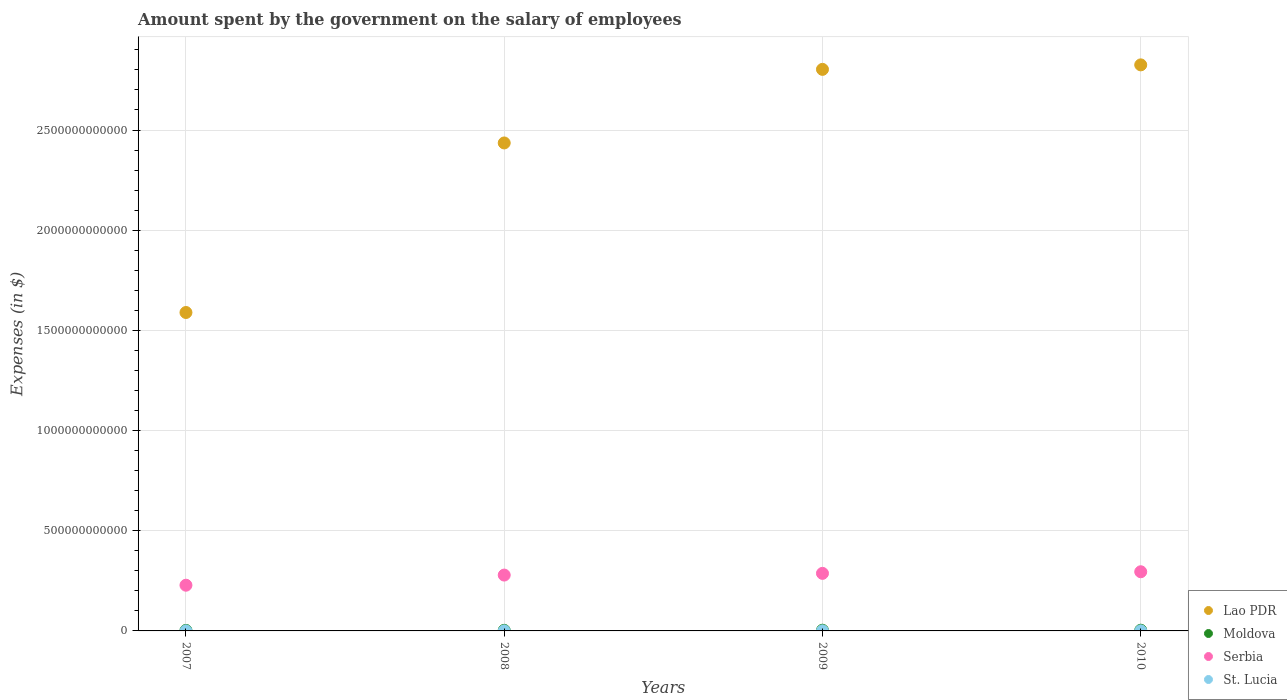What is the amount spent on the salary of employees by the government in Moldova in 2007?
Give a very brief answer. 2.63e+09. Across all years, what is the maximum amount spent on the salary of employees by the government in Lao PDR?
Offer a terse response. 2.83e+12. Across all years, what is the minimum amount spent on the salary of employees by the government in Moldova?
Make the answer very short. 2.63e+09. In which year was the amount spent on the salary of employees by the government in Serbia minimum?
Offer a very short reply. 2007. What is the total amount spent on the salary of employees by the government in Serbia in the graph?
Your answer should be compact. 1.09e+12. What is the difference between the amount spent on the salary of employees by the government in Lao PDR in 2008 and that in 2009?
Keep it short and to the point. -3.67e+11. What is the difference between the amount spent on the salary of employees by the government in Serbia in 2007 and the amount spent on the salary of employees by the government in Moldova in 2008?
Provide a short and direct response. 2.25e+11. What is the average amount spent on the salary of employees by the government in Lao PDR per year?
Provide a succinct answer. 2.41e+12. In the year 2007, what is the difference between the amount spent on the salary of employees by the government in St. Lucia and amount spent on the salary of employees by the government in Lao PDR?
Your answer should be very brief. -1.59e+12. What is the ratio of the amount spent on the salary of employees by the government in St. Lucia in 2008 to that in 2010?
Ensure brevity in your answer.  0.86. Is the amount spent on the salary of employees by the government in Lao PDR in 2009 less than that in 2010?
Offer a terse response. Yes. Is the difference between the amount spent on the salary of employees by the government in St. Lucia in 2007 and 2010 greater than the difference between the amount spent on the salary of employees by the government in Lao PDR in 2007 and 2010?
Your response must be concise. Yes. What is the difference between the highest and the second highest amount spent on the salary of employees by the government in Moldova?
Keep it short and to the point. 1.01e+07. What is the difference between the highest and the lowest amount spent on the salary of employees by the government in St. Lucia?
Ensure brevity in your answer.  8.42e+07. In how many years, is the amount spent on the salary of employees by the government in Lao PDR greater than the average amount spent on the salary of employees by the government in Lao PDR taken over all years?
Offer a terse response. 3. Is it the case that in every year, the sum of the amount spent on the salary of employees by the government in Moldova and amount spent on the salary of employees by the government in Lao PDR  is greater than the sum of amount spent on the salary of employees by the government in St. Lucia and amount spent on the salary of employees by the government in Serbia?
Your answer should be compact. No. Is it the case that in every year, the sum of the amount spent on the salary of employees by the government in Lao PDR and amount spent on the salary of employees by the government in Moldova  is greater than the amount spent on the salary of employees by the government in St. Lucia?
Your answer should be compact. Yes. Does the amount spent on the salary of employees by the government in St. Lucia monotonically increase over the years?
Keep it short and to the point. Yes. Is the amount spent on the salary of employees by the government in Serbia strictly greater than the amount spent on the salary of employees by the government in Moldova over the years?
Give a very brief answer. Yes. Is the amount spent on the salary of employees by the government in Lao PDR strictly less than the amount spent on the salary of employees by the government in St. Lucia over the years?
Give a very brief answer. No. How many dotlines are there?
Make the answer very short. 4. How many years are there in the graph?
Offer a terse response. 4. What is the difference between two consecutive major ticks on the Y-axis?
Ensure brevity in your answer.  5.00e+11. Are the values on the major ticks of Y-axis written in scientific E-notation?
Provide a short and direct response. No. Does the graph contain any zero values?
Your response must be concise. No. Does the graph contain grids?
Provide a short and direct response. Yes. What is the title of the graph?
Offer a terse response. Amount spent by the government on the salary of employees. What is the label or title of the Y-axis?
Offer a terse response. Expenses (in $). What is the Expenses (in $) in Lao PDR in 2007?
Your answer should be very brief. 1.59e+12. What is the Expenses (in $) in Moldova in 2007?
Make the answer very short. 2.63e+09. What is the Expenses (in $) of Serbia in 2007?
Offer a terse response. 2.28e+11. What is the Expenses (in $) of St. Lucia in 2007?
Provide a short and direct response. 2.52e+08. What is the Expenses (in $) of Lao PDR in 2008?
Ensure brevity in your answer.  2.44e+12. What is the Expenses (in $) of Moldova in 2008?
Your answer should be compact. 2.94e+09. What is the Expenses (in $) of Serbia in 2008?
Offer a very short reply. 2.79e+11. What is the Expenses (in $) in St. Lucia in 2008?
Make the answer very short. 2.88e+08. What is the Expenses (in $) in Lao PDR in 2009?
Your response must be concise. 2.80e+12. What is the Expenses (in $) of Moldova in 2009?
Offer a very short reply. 3.47e+09. What is the Expenses (in $) in Serbia in 2009?
Provide a succinct answer. 2.87e+11. What is the Expenses (in $) of St. Lucia in 2009?
Offer a terse response. 3.09e+08. What is the Expenses (in $) in Lao PDR in 2010?
Ensure brevity in your answer.  2.83e+12. What is the Expenses (in $) of Moldova in 2010?
Keep it short and to the point. 3.46e+09. What is the Expenses (in $) of Serbia in 2010?
Provide a succinct answer. 2.95e+11. What is the Expenses (in $) in St. Lucia in 2010?
Ensure brevity in your answer.  3.37e+08. Across all years, what is the maximum Expenses (in $) in Lao PDR?
Keep it short and to the point. 2.83e+12. Across all years, what is the maximum Expenses (in $) in Moldova?
Your answer should be very brief. 3.47e+09. Across all years, what is the maximum Expenses (in $) in Serbia?
Your response must be concise. 2.95e+11. Across all years, what is the maximum Expenses (in $) in St. Lucia?
Provide a short and direct response. 3.37e+08. Across all years, what is the minimum Expenses (in $) in Lao PDR?
Keep it short and to the point. 1.59e+12. Across all years, what is the minimum Expenses (in $) in Moldova?
Your answer should be very brief. 2.63e+09. Across all years, what is the minimum Expenses (in $) in Serbia?
Provide a short and direct response. 2.28e+11. Across all years, what is the minimum Expenses (in $) of St. Lucia?
Give a very brief answer. 2.52e+08. What is the total Expenses (in $) in Lao PDR in the graph?
Your response must be concise. 9.65e+12. What is the total Expenses (in $) of Moldova in the graph?
Keep it short and to the point. 1.25e+1. What is the total Expenses (in $) in Serbia in the graph?
Your response must be concise. 1.09e+12. What is the total Expenses (in $) of St. Lucia in the graph?
Ensure brevity in your answer.  1.19e+09. What is the difference between the Expenses (in $) of Lao PDR in 2007 and that in 2008?
Keep it short and to the point. -8.46e+11. What is the difference between the Expenses (in $) in Moldova in 2007 and that in 2008?
Your response must be concise. -3.10e+08. What is the difference between the Expenses (in $) in Serbia in 2007 and that in 2008?
Your answer should be very brief. -5.06e+1. What is the difference between the Expenses (in $) of St. Lucia in 2007 and that in 2008?
Your response must be concise. -3.59e+07. What is the difference between the Expenses (in $) of Lao PDR in 2007 and that in 2009?
Your answer should be compact. -1.21e+12. What is the difference between the Expenses (in $) of Moldova in 2007 and that in 2009?
Your answer should be compact. -8.34e+08. What is the difference between the Expenses (in $) of Serbia in 2007 and that in 2009?
Provide a succinct answer. -5.91e+1. What is the difference between the Expenses (in $) of St. Lucia in 2007 and that in 2009?
Your answer should be very brief. -5.66e+07. What is the difference between the Expenses (in $) of Lao PDR in 2007 and that in 2010?
Give a very brief answer. -1.24e+12. What is the difference between the Expenses (in $) in Moldova in 2007 and that in 2010?
Provide a short and direct response. -8.24e+08. What is the difference between the Expenses (in $) of Serbia in 2007 and that in 2010?
Provide a succinct answer. -6.72e+1. What is the difference between the Expenses (in $) in St. Lucia in 2007 and that in 2010?
Provide a short and direct response. -8.42e+07. What is the difference between the Expenses (in $) of Lao PDR in 2008 and that in 2009?
Your answer should be compact. -3.67e+11. What is the difference between the Expenses (in $) in Moldova in 2008 and that in 2009?
Give a very brief answer. -5.25e+08. What is the difference between the Expenses (in $) of Serbia in 2008 and that in 2009?
Give a very brief answer. -8.54e+09. What is the difference between the Expenses (in $) in St. Lucia in 2008 and that in 2009?
Keep it short and to the point. -2.07e+07. What is the difference between the Expenses (in $) in Lao PDR in 2008 and that in 2010?
Give a very brief answer. -3.90e+11. What is the difference between the Expenses (in $) in Moldova in 2008 and that in 2010?
Ensure brevity in your answer.  -5.14e+08. What is the difference between the Expenses (in $) in Serbia in 2008 and that in 2010?
Provide a short and direct response. -1.66e+1. What is the difference between the Expenses (in $) of St. Lucia in 2008 and that in 2010?
Provide a succinct answer. -4.83e+07. What is the difference between the Expenses (in $) in Lao PDR in 2009 and that in 2010?
Ensure brevity in your answer.  -2.24e+1. What is the difference between the Expenses (in $) of Moldova in 2009 and that in 2010?
Keep it short and to the point. 1.01e+07. What is the difference between the Expenses (in $) in Serbia in 2009 and that in 2010?
Offer a terse response. -8.06e+09. What is the difference between the Expenses (in $) of St. Lucia in 2009 and that in 2010?
Give a very brief answer. -2.76e+07. What is the difference between the Expenses (in $) in Lao PDR in 2007 and the Expenses (in $) in Moldova in 2008?
Offer a very short reply. 1.59e+12. What is the difference between the Expenses (in $) in Lao PDR in 2007 and the Expenses (in $) in Serbia in 2008?
Your response must be concise. 1.31e+12. What is the difference between the Expenses (in $) of Lao PDR in 2007 and the Expenses (in $) of St. Lucia in 2008?
Your answer should be very brief. 1.59e+12. What is the difference between the Expenses (in $) of Moldova in 2007 and the Expenses (in $) of Serbia in 2008?
Ensure brevity in your answer.  -2.76e+11. What is the difference between the Expenses (in $) of Moldova in 2007 and the Expenses (in $) of St. Lucia in 2008?
Offer a very short reply. 2.35e+09. What is the difference between the Expenses (in $) in Serbia in 2007 and the Expenses (in $) in St. Lucia in 2008?
Offer a terse response. 2.28e+11. What is the difference between the Expenses (in $) in Lao PDR in 2007 and the Expenses (in $) in Moldova in 2009?
Your answer should be very brief. 1.59e+12. What is the difference between the Expenses (in $) of Lao PDR in 2007 and the Expenses (in $) of Serbia in 2009?
Your answer should be compact. 1.30e+12. What is the difference between the Expenses (in $) of Lao PDR in 2007 and the Expenses (in $) of St. Lucia in 2009?
Give a very brief answer. 1.59e+12. What is the difference between the Expenses (in $) of Moldova in 2007 and the Expenses (in $) of Serbia in 2009?
Keep it short and to the point. -2.85e+11. What is the difference between the Expenses (in $) in Moldova in 2007 and the Expenses (in $) in St. Lucia in 2009?
Provide a succinct answer. 2.33e+09. What is the difference between the Expenses (in $) of Serbia in 2007 and the Expenses (in $) of St. Lucia in 2009?
Your response must be concise. 2.28e+11. What is the difference between the Expenses (in $) in Lao PDR in 2007 and the Expenses (in $) in Moldova in 2010?
Give a very brief answer. 1.59e+12. What is the difference between the Expenses (in $) in Lao PDR in 2007 and the Expenses (in $) in Serbia in 2010?
Your answer should be compact. 1.29e+12. What is the difference between the Expenses (in $) in Lao PDR in 2007 and the Expenses (in $) in St. Lucia in 2010?
Provide a succinct answer. 1.59e+12. What is the difference between the Expenses (in $) of Moldova in 2007 and the Expenses (in $) of Serbia in 2010?
Provide a succinct answer. -2.93e+11. What is the difference between the Expenses (in $) in Moldova in 2007 and the Expenses (in $) in St. Lucia in 2010?
Make the answer very short. 2.30e+09. What is the difference between the Expenses (in $) of Serbia in 2007 and the Expenses (in $) of St. Lucia in 2010?
Your answer should be very brief. 2.28e+11. What is the difference between the Expenses (in $) in Lao PDR in 2008 and the Expenses (in $) in Moldova in 2009?
Offer a terse response. 2.43e+12. What is the difference between the Expenses (in $) in Lao PDR in 2008 and the Expenses (in $) in Serbia in 2009?
Provide a short and direct response. 2.15e+12. What is the difference between the Expenses (in $) in Lao PDR in 2008 and the Expenses (in $) in St. Lucia in 2009?
Your answer should be very brief. 2.44e+12. What is the difference between the Expenses (in $) in Moldova in 2008 and the Expenses (in $) in Serbia in 2009?
Ensure brevity in your answer.  -2.84e+11. What is the difference between the Expenses (in $) in Moldova in 2008 and the Expenses (in $) in St. Lucia in 2009?
Ensure brevity in your answer.  2.64e+09. What is the difference between the Expenses (in $) in Serbia in 2008 and the Expenses (in $) in St. Lucia in 2009?
Provide a succinct answer. 2.78e+11. What is the difference between the Expenses (in $) in Lao PDR in 2008 and the Expenses (in $) in Moldova in 2010?
Ensure brevity in your answer.  2.43e+12. What is the difference between the Expenses (in $) in Lao PDR in 2008 and the Expenses (in $) in Serbia in 2010?
Your response must be concise. 2.14e+12. What is the difference between the Expenses (in $) in Lao PDR in 2008 and the Expenses (in $) in St. Lucia in 2010?
Give a very brief answer. 2.44e+12. What is the difference between the Expenses (in $) in Moldova in 2008 and the Expenses (in $) in Serbia in 2010?
Your answer should be very brief. -2.92e+11. What is the difference between the Expenses (in $) in Moldova in 2008 and the Expenses (in $) in St. Lucia in 2010?
Offer a terse response. 2.61e+09. What is the difference between the Expenses (in $) in Serbia in 2008 and the Expenses (in $) in St. Lucia in 2010?
Offer a terse response. 2.78e+11. What is the difference between the Expenses (in $) of Lao PDR in 2009 and the Expenses (in $) of Moldova in 2010?
Give a very brief answer. 2.80e+12. What is the difference between the Expenses (in $) in Lao PDR in 2009 and the Expenses (in $) in Serbia in 2010?
Your answer should be compact. 2.51e+12. What is the difference between the Expenses (in $) of Lao PDR in 2009 and the Expenses (in $) of St. Lucia in 2010?
Your answer should be very brief. 2.80e+12. What is the difference between the Expenses (in $) in Moldova in 2009 and the Expenses (in $) in Serbia in 2010?
Ensure brevity in your answer.  -2.92e+11. What is the difference between the Expenses (in $) in Moldova in 2009 and the Expenses (in $) in St. Lucia in 2010?
Keep it short and to the point. 3.13e+09. What is the difference between the Expenses (in $) of Serbia in 2009 and the Expenses (in $) of St. Lucia in 2010?
Your response must be concise. 2.87e+11. What is the average Expenses (in $) in Lao PDR per year?
Your answer should be compact. 2.41e+12. What is the average Expenses (in $) in Moldova per year?
Ensure brevity in your answer.  3.13e+09. What is the average Expenses (in $) of Serbia per year?
Offer a very short reply. 2.72e+11. What is the average Expenses (in $) of St. Lucia per year?
Give a very brief answer. 2.97e+08. In the year 2007, what is the difference between the Expenses (in $) in Lao PDR and Expenses (in $) in Moldova?
Keep it short and to the point. 1.59e+12. In the year 2007, what is the difference between the Expenses (in $) in Lao PDR and Expenses (in $) in Serbia?
Give a very brief answer. 1.36e+12. In the year 2007, what is the difference between the Expenses (in $) of Lao PDR and Expenses (in $) of St. Lucia?
Offer a terse response. 1.59e+12. In the year 2007, what is the difference between the Expenses (in $) of Moldova and Expenses (in $) of Serbia?
Provide a succinct answer. -2.26e+11. In the year 2007, what is the difference between the Expenses (in $) of Moldova and Expenses (in $) of St. Lucia?
Provide a succinct answer. 2.38e+09. In the year 2007, what is the difference between the Expenses (in $) in Serbia and Expenses (in $) in St. Lucia?
Your answer should be very brief. 2.28e+11. In the year 2008, what is the difference between the Expenses (in $) in Lao PDR and Expenses (in $) in Moldova?
Make the answer very short. 2.43e+12. In the year 2008, what is the difference between the Expenses (in $) in Lao PDR and Expenses (in $) in Serbia?
Make the answer very short. 2.16e+12. In the year 2008, what is the difference between the Expenses (in $) of Lao PDR and Expenses (in $) of St. Lucia?
Offer a terse response. 2.44e+12. In the year 2008, what is the difference between the Expenses (in $) in Moldova and Expenses (in $) in Serbia?
Make the answer very short. -2.76e+11. In the year 2008, what is the difference between the Expenses (in $) of Moldova and Expenses (in $) of St. Lucia?
Make the answer very short. 2.66e+09. In the year 2008, what is the difference between the Expenses (in $) of Serbia and Expenses (in $) of St. Lucia?
Keep it short and to the point. 2.78e+11. In the year 2009, what is the difference between the Expenses (in $) in Lao PDR and Expenses (in $) in Moldova?
Keep it short and to the point. 2.80e+12. In the year 2009, what is the difference between the Expenses (in $) of Lao PDR and Expenses (in $) of Serbia?
Your answer should be compact. 2.52e+12. In the year 2009, what is the difference between the Expenses (in $) in Lao PDR and Expenses (in $) in St. Lucia?
Offer a terse response. 2.80e+12. In the year 2009, what is the difference between the Expenses (in $) of Moldova and Expenses (in $) of Serbia?
Ensure brevity in your answer.  -2.84e+11. In the year 2009, what is the difference between the Expenses (in $) of Moldova and Expenses (in $) of St. Lucia?
Your response must be concise. 3.16e+09. In the year 2009, what is the difference between the Expenses (in $) in Serbia and Expenses (in $) in St. Lucia?
Your response must be concise. 2.87e+11. In the year 2010, what is the difference between the Expenses (in $) of Lao PDR and Expenses (in $) of Moldova?
Your response must be concise. 2.82e+12. In the year 2010, what is the difference between the Expenses (in $) of Lao PDR and Expenses (in $) of Serbia?
Ensure brevity in your answer.  2.53e+12. In the year 2010, what is the difference between the Expenses (in $) of Lao PDR and Expenses (in $) of St. Lucia?
Offer a very short reply. 2.82e+12. In the year 2010, what is the difference between the Expenses (in $) of Moldova and Expenses (in $) of Serbia?
Your answer should be compact. -2.92e+11. In the year 2010, what is the difference between the Expenses (in $) in Moldova and Expenses (in $) in St. Lucia?
Ensure brevity in your answer.  3.12e+09. In the year 2010, what is the difference between the Expenses (in $) in Serbia and Expenses (in $) in St. Lucia?
Your response must be concise. 2.95e+11. What is the ratio of the Expenses (in $) of Lao PDR in 2007 to that in 2008?
Offer a very short reply. 0.65. What is the ratio of the Expenses (in $) in Moldova in 2007 to that in 2008?
Your answer should be compact. 0.89. What is the ratio of the Expenses (in $) of Serbia in 2007 to that in 2008?
Your response must be concise. 0.82. What is the ratio of the Expenses (in $) of St. Lucia in 2007 to that in 2008?
Provide a short and direct response. 0.88. What is the ratio of the Expenses (in $) in Lao PDR in 2007 to that in 2009?
Provide a succinct answer. 0.57. What is the ratio of the Expenses (in $) in Moldova in 2007 to that in 2009?
Make the answer very short. 0.76. What is the ratio of the Expenses (in $) in Serbia in 2007 to that in 2009?
Give a very brief answer. 0.79. What is the ratio of the Expenses (in $) of St. Lucia in 2007 to that in 2009?
Your response must be concise. 0.82. What is the ratio of the Expenses (in $) of Lao PDR in 2007 to that in 2010?
Your response must be concise. 0.56. What is the ratio of the Expenses (in $) of Moldova in 2007 to that in 2010?
Make the answer very short. 0.76. What is the ratio of the Expenses (in $) of Serbia in 2007 to that in 2010?
Keep it short and to the point. 0.77. What is the ratio of the Expenses (in $) in St. Lucia in 2007 to that in 2010?
Give a very brief answer. 0.75. What is the ratio of the Expenses (in $) of Lao PDR in 2008 to that in 2009?
Ensure brevity in your answer.  0.87. What is the ratio of the Expenses (in $) in Moldova in 2008 to that in 2009?
Make the answer very short. 0.85. What is the ratio of the Expenses (in $) in Serbia in 2008 to that in 2009?
Ensure brevity in your answer.  0.97. What is the ratio of the Expenses (in $) of St. Lucia in 2008 to that in 2009?
Offer a terse response. 0.93. What is the ratio of the Expenses (in $) in Lao PDR in 2008 to that in 2010?
Your response must be concise. 0.86. What is the ratio of the Expenses (in $) in Moldova in 2008 to that in 2010?
Your answer should be compact. 0.85. What is the ratio of the Expenses (in $) of Serbia in 2008 to that in 2010?
Keep it short and to the point. 0.94. What is the ratio of the Expenses (in $) of St. Lucia in 2008 to that in 2010?
Make the answer very short. 0.86. What is the ratio of the Expenses (in $) in Moldova in 2009 to that in 2010?
Provide a succinct answer. 1. What is the ratio of the Expenses (in $) in Serbia in 2009 to that in 2010?
Give a very brief answer. 0.97. What is the ratio of the Expenses (in $) in St. Lucia in 2009 to that in 2010?
Your answer should be compact. 0.92. What is the difference between the highest and the second highest Expenses (in $) in Lao PDR?
Your response must be concise. 2.24e+1. What is the difference between the highest and the second highest Expenses (in $) of Moldova?
Provide a succinct answer. 1.01e+07. What is the difference between the highest and the second highest Expenses (in $) of Serbia?
Give a very brief answer. 8.06e+09. What is the difference between the highest and the second highest Expenses (in $) of St. Lucia?
Your response must be concise. 2.76e+07. What is the difference between the highest and the lowest Expenses (in $) in Lao PDR?
Ensure brevity in your answer.  1.24e+12. What is the difference between the highest and the lowest Expenses (in $) of Moldova?
Provide a short and direct response. 8.34e+08. What is the difference between the highest and the lowest Expenses (in $) in Serbia?
Keep it short and to the point. 6.72e+1. What is the difference between the highest and the lowest Expenses (in $) in St. Lucia?
Ensure brevity in your answer.  8.42e+07. 